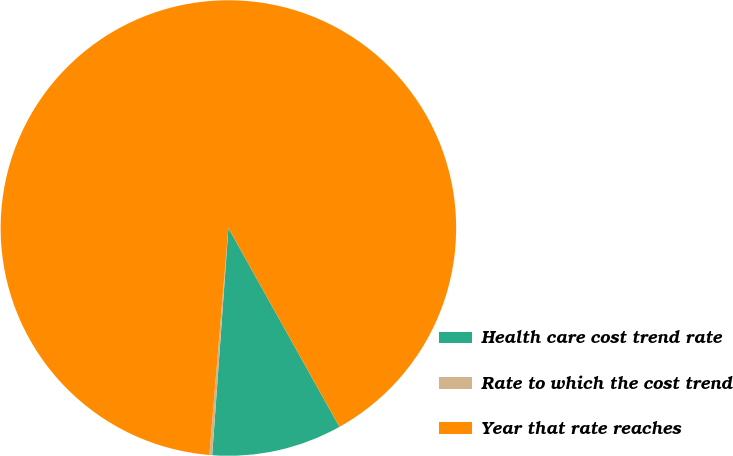Convert chart to OTSL. <chart><loc_0><loc_0><loc_500><loc_500><pie_chart><fcel>Health care cost trend rate<fcel>Rate to which the cost trend<fcel>Year that rate reaches<nl><fcel>9.24%<fcel>0.2%<fcel>90.56%<nl></chart> 